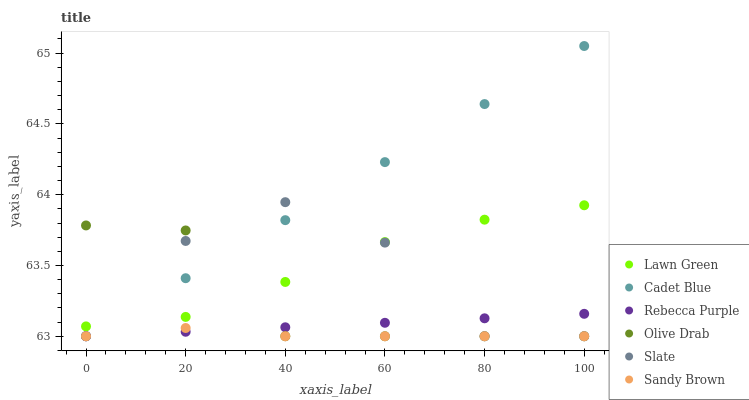Does Sandy Brown have the minimum area under the curve?
Answer yes or no. Yes. Does Cadet Blue have the maximum area under the curve?
Answer yes or no. Yes. Does Slate have the minimum area under the curve?
Answer yes or no. No. Does Slate have the maximum area under the curve?
Answer yes or no. No. Is Rebecca Purple the smoothest?
Answer yes or no. Yes. Is Slate the roughest?
Answer yes or no. Yes. Is Cadet Blue the smoothest?
Answer yes or no. No. Is Cadet Blue the roughest?
Answer yes or no. No. Does Cadet Blue have the lowest value?
Answer yes or no. Yes. Does Cadet Blue have the highest value?
Answer yes or no. Yes. Does Slate have the highest value?
Answer yes or no. No. Is Rebecca Purple less than Lawn Green?
Answer yes or no. Yes. Is Lawn Green greater than Rebecca Purple?
Answer yes or no. Yes. Does Sandy Brown intersect Rebecca Purple?
Answer yes or no. Yes. Is Sandy Brown less than Rebecca Purple?
Answer yes or no. No. Is Sandy Brown greater than Rebecca Purple?
Answer yes or no. No. Does Rebecca Purple intersect Lawn Green?
Answer yes or no. No. 